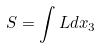Convert formula to latex. <formula><loc_0><loc_0><loc_500><loc_500>S = \int L d x _ { 3 }</formula> 